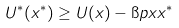<formula> <loc_0><loc_0><loc_500><loc_500>U ^ { * } ( x ^ { * } ) \geq U ( x ) - \i p x { x ^ { * } }</formula> 